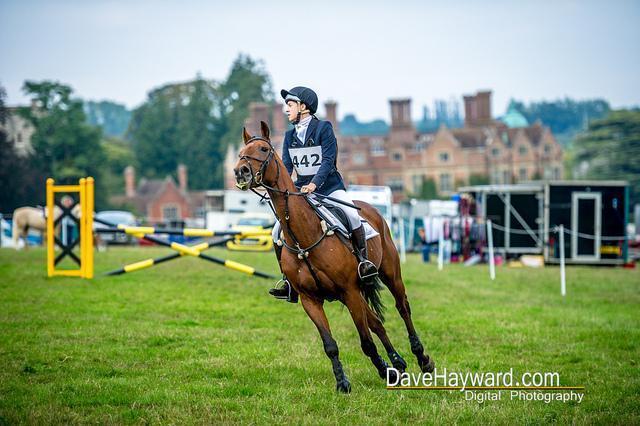How many wheels are in the photo?
Give a very brief answer. 0. How many kites are flying?
Give a very brief answer. 0. 